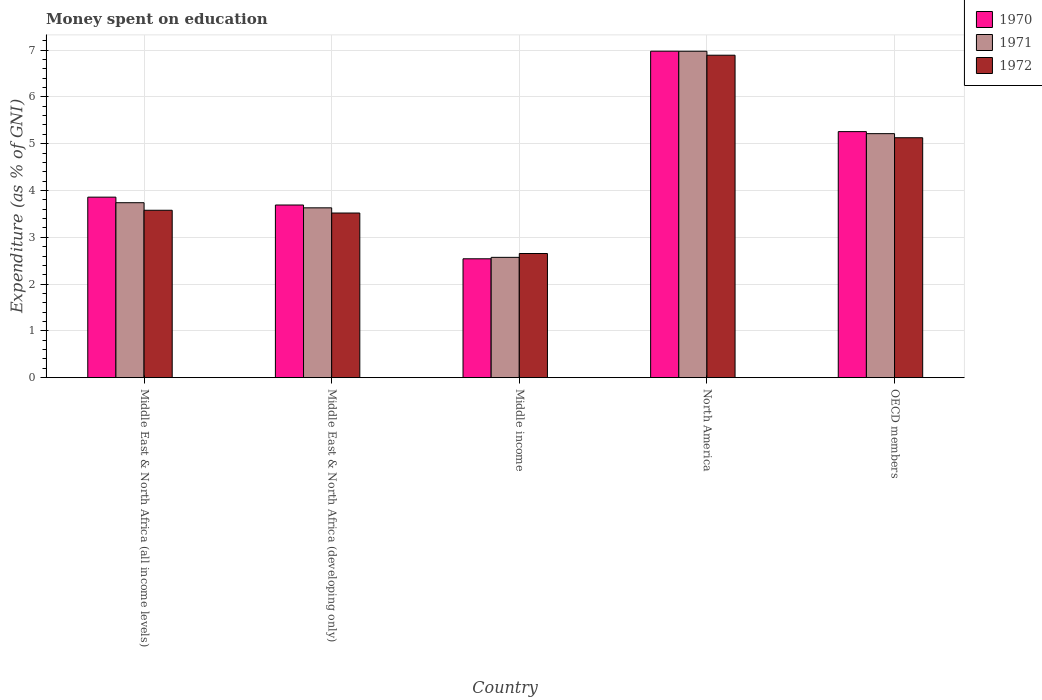How many different coloured bars are there?
Your answer should be very brief. 3. Are the number of bars on each tick of the X-axis equal?
Ensure brevity in your answer.  Yes. How many bars are there on the 3rd tick from the left?
Your answer should be compact. 3. What is the label of the 5th group of bars from the left?
Your answer should be very brief. OECD members. What is the amount of money spent on education in 1970 in Middle East & North Africa (developing only)?
Give a very brief answer. 3.69. Across all countries, what is the maximum amount of money spent on education in 1972?
Keep it short and to the point. 6.89. Across all countries, what is the minimum amount of money spent on education in 1971?
Offer a very short reply. 2.57. What is the total amount of money spent on education in 1972 in the graph?
Keep it short and to the point. 21.77. What is the difference between the amount of money spent on education in 1972 in Middle East & North Africa (developing only) and that in Middle income?
Make the answer very short. 0.87. What is the difference between the amount of money spent on education in 1970 in OECD members and the amount of money spent on education in 1972 in Middle income?
Offer a terse response. 2.6. What is the average amount of money spent on education in 1972 per country?
Offer a very short reply. 4.35. What is the difference between the amount of money spent on education of/in 1972 and amount of money spent on education of/in 1970 in Middle East & North Africa (all income levels)?
Give a very brief answer. -0.28. What is the ratio of the amount of money spent on education in 1970 in Middle East & North Africa (all income levels) to that in North America?
Your answer should be very brief. 0.55. Is the amount of money spent on education in 1972 in Middle East & North Africa (all income levels) less than that in OECD members?
Make the answer very short. Yes. Is the difference between the amount of money spent on education in 1972 in Middle East & North Africa (all income levels) and Middle income greater than the difference between the amount of money spent on education in 1970 in Middle East & North Africa (all income levels) and Middle income?
Provide a short and direct response. No. What is the difference between the highest and the second highest amount of money spent on education in 1970?
Ensure brevity in your answer.  -1.4. What is the difference between the highest and the lowest amount of money spent on education in 1970?
Give a very brief answer. 4.44. Is it the case that in every country, the sum of the amount of money spent on education in 1972 and amount of money spent on education in 1971 is greater than the amount of money spent on education in 1970?
Your answer should be very brief. Yes. How many bars are there?
Your answer should be very brief. 15. Does the graph contain any zero values?
Provide a short and direct response. No. Where does the legend appear in the graph?
Give a very brief answer. Top right. How are the legend labels stacked?
Provide a short and direct response. Vertical. What is the title of the graph?
Provide a short and direct response. Money spent on education. What is the label or title of the Y-axis?
Offer a very short reply. Expenditure (as % of GNI). What is the Expenditure (as % of GNI) in 1970 in Middle East & North Africa (all income levels)?
Ensure brevity in your answer.  3.86. What is the Expenditure (as % of GNI) of 1971 in Middle East & North Africa (all income levels)?
Provide a short and direct response. 3.74. What is the Expenditure (as % of GNI) in 1972 in Middle East & North Africa (all income levels)?
Give a very brief answer. 3.58. What is the Expenditure (as % of GNI) of 1970 in Middle East & North Africa (developing only)?
Ensure brevity in your answer.  3.69. What is the Expenditure (as % of GNI) of 1971 in Middle East & North Africa (developing only)?
Ensure brevity in your answer.  3.63. What is the Expenditure (as % of GNI) of 1972 in Middle East & North Africa (developing only)?
Offer a terse response. 3.52. What is the Expenditure (as % of GNI) in 1970 in Middle income?
Ensure brevity in your answer.  2.54. What is the Expenditure (as % of GNI) of 1971 in Middle income?
Your response must be concise. 2.57. What is the Expenditure (as % of GNI) of 1972 in Middle income?
Offer a terse response. 2.65. What is the Expenditure (as % of GNI) in 1970 in North America?
Your answer should be compact. 6.98. What is the Expenditure (as % of GNI) of 1971 in North America?
Give a very brief answer. 6.98. What is the Expenditure (as % of GNI) in 1972 in North America?
Your answer should be very brief. 6.89. What is the Expenditure (as % of GNI) in 1970 in OECD members?
Provide a succinct answer. 5.26. What is the Expenditure (as % of GNI) in 1971 in OECD members?
Provide a succinct answer. 5.21. What is the Expenditure (as % of GNI) of 1972 in OECD members?
Your response must be concise. 5.13. Across all countries, what is the maximum Expenditure (as % of GNI) of 1970?
Offer a terse response. 6.98. Across all countries, what is the maximum Expenditure (as % of GNI) of 1971?
Offer a terse response. 6.98. Across all countries, what is the maximum Expenditure (as % of GNI) in 1972?
Offer a terse response. 6.89. Across all countries, what is the minimum Expenditure (as % of GNI) in 1970?
Provide a succinct answer. 2.54. Across all countries, what is the minimum Expenditure (as % of GNI) in 1971?
Give a very brief answer. 2.57. Across all countries, what is the minimum Expenditure (as % of GNI) of 1972?
Your answer should be compact. 2.65. What is the total Expenditure (as % of GNI) of 1970 in the graph?
Give a very brief answer. 22.32. What is the total Expenditure (as % of GNI) in 1971 in the graph?
Offer a very short reply. 22.13. What is the total Expenditure (as % of GNI) of 1972 in the graph?
Offer a very short reply. 21.77. What is the difference between the Expenditure (as % of GNI) of 1970 in Middle East & North Africa (all income levels) and that in Middle East & North Africa (developing only)?
Keep it short and to the point. 0.17. What is the difference between the Expenditure (as % of GNI) of 1971 in Middle East & North Africa (all income levels) and that in Middle East & North Africa (developing only)?
Offer a terse response. 0.11. What is the difference between the Expenditure (as % of GNI) in 1972 in Middle East & North Africa (all income levels) and that in Middle East & North Africa (developing only)?
Your answer should be compact. 0.06. What is the difference between the Expenditure (as % of GNI) of 1970 in Middle East & North Africa (all income levels) and that in Middle income?
Provide a short and direct response. 1.32. What is the difference between the Expenditure (as % of GNI) in 1971 in Middle East & North Africa (all income levels) and that in Middle income?
Your answer should be very brief. 1.17. What is the difference between the Expenditure (as % of GNI) of 1972 in Middle East & North Africa (all income levels) and that in Middle income?
Provide a short and direct response. 0.92. What is the difference between the Expenditure (as % of GNI) of 1970 in Middle East & North Africa (all income levels) and that in North America?
Your response must be concise. -3.12. What is the difference between the Expenditure (as % of GNI) of 1971 in Middle East & North Africa (all income levels) and that in North America?
Provide a succinct answer. -3.24. What is the difference between the Expenditure (as % of GNI) in 1972 in Middle East & North Africa (all income levels) and that in North America?
Ensure brevity in your answer.  -3.31. What is the difference between the Expenditure (as % of GNI) of 1970 in Middle East & North Africa (all income levels) and that in OECD members?
Make the answer very short. -1.4. What is the difference between the Expenditure (as % of GNI) of 1971 in Middle East & North Africa (all income levels) and that in OECD members?
Provide a succinct answer. -1.48. What is the difference between the Expenditure (as % of GNI) of 1972 in Middle East & North Africa (all income levels) and that in OECD members?
Your answer should be compact. -1.55. What is the difference between the Expenditure (as % of GNI) of 1970 in Middle East & North Africa (developing only) and that in Middle income?
Ensure brevity in your answer.  1.15. What is the difference between the Expenditure (as % of GNI) in 1971 in Middle East & North Africa (developing only) and that in Middle income?
Your answer should be compact. 1.06. What is the difference between the Expenditure (as % of GNI) in 1972 in Middle East & North Africa (developing only) and that in Middle income?
Your response must be concise. 0.86. What is the difference between the Expenditure (as % of GNI) of 1970 in Middle East & North Africa (developing only) and that in North America?
Keep it short and to the point. -3.29. What is the difference between the Expenditure (as % of GNI) in 1971 in Middle East & North Africa (developing only) and that in North America?
Offer a terse response. -3.35. What is the difference between the Expenditure (as % of GNI) in 1972 in Middle East & North Africa (developing only) and that in North America?
Provide a succinct answer. -3.37. What is the difference between the Expenditure (as % of GNI) of 1970 in Middle East & North Africa (developing only) and that in OECD members?
Make the answer very short. -1.57. What is the difference between the Expenditure (as % of GNI) in 1971 in Middle East & North Africa (developing only) and that in OECD members?
Your answer should be compact. -1.59. What is the difference between the Expenditure (as % of GNI) in 1972 in Middle East & North Africa (developing only) and that in OECD members?
Your answer should be compact. -1.61. What is the difference between the Expenditure (as % of GNI) in 1970 in Middle income and that in North America?
Provide a succinct answer. -4.44. What is the difference between the Expenditure (as % of GNI) in 1971 in Middle income and that in North America?
Your response must be concise. -4.41. What is the difference between the Expenditure (as % of GNI) in 1972 in Middle income and that in North America?
Offer a very short reply. -4.24. What is the difference between the Expenditure (as % of GNI) of 1970 in Middle income and that in OECD members?
Make the answer very short. -2.72. What is the difference between the Expenditure (as % of GNI) in 1971 in Middle income and that in OECD members?
Offer a very short reply. -2.64. What is the difference between the Expenditure (as % of GNI) of 1972 in Middle income and that in OECD members?
Make the answer very short. -2.47. What is the difference between the Expenditure (as % of GNI) of 1970 in North America and that in OECD members?
Provide a short and direct response. 1.72. What is the difference between the Expenditure (as % of GNI) in 1971 in North America and that in OECD members?
Offer a terse response. 1.76. What is the difference between the Expenditure (as % of GNI) of 1972 in North America and that in OECD members?
Your response must be concise. 1.76. What is the difference between the Expenditure (as % of GNI) in 1970 in Middle East & North Africa (all income levels) and the Expenditure (as % of GNI) in 1971 in Middle East & North Africa (developing only)?
Offer a very short reply. 0.23. What is the difference between the Expenditure (as % of GNI) in 1970 in Middle East & North Africa (all income levels) and the Expenditure (as % of GNI) in 1972 in Middle East & North Africa (developing only)?
Provide a succinct answer. 0.34. What is the difference between the Expenditure (as % of GNI) in 1971 in Middle East & North Africa (all income levels) and the Expenditure (as % of GNI) in 1972 in Middle East & North Africa (developing only)?
Your answer should be very brief. 0.22. What is the difference between the Expenditure (as % of GNI) of 1970 in Middle East & North Africa (all income levels) and the Expenditure (as % of GNI) of 1971 in Middle income?
Your answer should be very brief. 1.29. What is the difference between the Expenditure (as % of GNI) of 1970 in Middle East & North Africa (all income levels) and the Expenditure (as % of GNI) of 1972 in Middle income?
Your answer should be very brief. 1.2. What is the difference between the Expenditure (as % of GNI) in 1971 in Middle East & North Africa (all income levels) and the Expenditure (as % of GNI) in 1972 in Middle income?
Your answer should be very brief. 1.09. What is the difference between the Expenditure (as % of GNI) of 1970 in Middle East & North Africa (all income levels) and the Expenditure (as % of GNI) of 1971 in North America?
Your answer should be very brief. -3.12. What is the difference between the Expenditure (as % of GNI) in 1970 in Middle East & North Africa (all income levels) and the Expenditure (as % of GNI) in 1972 in North America?
Ensure brevity in your answer.  -3.03. What is the difference between the Expenditure (as % of GNI) of 1971 in Middle East & North Africa (all income levels) and the Expenditure (as % of GNI) of 1972 in North America?
Make the answer very short. -3.15. What is the difference between the Expenditure (as % of GNI) in 1970 in Middle East & North Africa (all income levels) and the Expenditure (as % of GNI) in 1971 in OECD members?
Give a very brief answer. -1.36. What is the difference between the Expenditure (as % of GNI) of 1970 in Middle East & North Africa (all income levels) and the Expenditure (as % of GNI) of 1972 in OECD members?
Keep it short and to the point. -1.27. What is the difference between the Expenditure (as % of GNI) in 1971 in Middle East & North Africa (all income levels) and the Expenditure (as % of GNI) in 1972 in OECD members?
Provide a short and direct response. -1.39. What is the difference between the Expenditure (as % of GNI) of 1970 in Middle East & North Africa (developing only) and the Expenditure (as % of GNI) of 1971 in Middle income?
Your response must be concise. 1.12. What is the difference between the Expenditure (as % of GNI) of 1970 in Middle East & North Africa (developing only) and the Expenditure (as % of GNI) of 1972 in Middle income?
Offer a terse response. 1.04. What is the difference between the Expenditure (as % of GNI) in 1971 in Middle East & North Africa (developing only) and the Expenditure (as % of GNI) in 1972 in Middle income?
Ensure brevity in your answer.  0.98. What is the difference between the Expenditure (as % of GNI) of 1970 in Middle East & North Africa (developing only) and the Expenditure (as % of GNI) of 1971 in North America?
Keep it short and to the point. -3.29. What is the difference between the Expenditure (as % of GNI) in 1970 in Middle East & North Africa (developing only) and the Expenditure (as % of GNI) in 1972 in North America?
Your answer should be compact. -3.2. What is the difference between the Expenditure (as % of GNI) of 1971 in Middle East & North Africa (developing only) and the Expenditure (as % of GNI) of 1972 in North America?
Keep it short and to the point. -3.26. What is the difference between the Expenditure (as % of GNI) of 1970 in Middle East & North Africa (developing only) and the Expenditure (as % of GNI) of 1971 in OECD members?
Provide a short and direct response. -1.52. What is the difference between the Expenditure (as % of GNI) of 1970 in Middle East & North Africa (developing only) and the Expenditure (as % of GNI) of 1972 in OECD members?
Give a very brief answer. -1.44. What is the difference between the Expenditure (as % of GNI) of 1971 in Middle East & North Africa (developing only) and the Expenditure (as % of GNI) of 1972 in OECD members?
Give a very brief answer. -1.5. What is the difference between the Expenditure (as % of GNI) of 1970 in Middle income and the Expenditure (as % of GNI) of 1971 in North America?
Your answer should be very brief. -4.44. What is the difference between the Expenditure (as % of GNI) in 1970 in Middle income and the Expenditure (as % of GNI) in 1972 in North America?
Keep it short and to the point. -4.35. What is the difference between the Expenditure (as % of GNI) of 1971 in Middle income and the Expenditure (as % of GNI) of 1972 in North America?
Keep it short and to the point. -4.32. What is the difference between the Expenditure (as % of GNI) in 1970 in Middle income and the Expenditure (as % of GNI) in 1971 in OECD members?
Your response must be concise. -2.67. What is the difference between the Expenditure (as % of GNI) in 1970 in Middle income and the Expenditure (as % of GNI) in 1972 in OECD members?
Provide a short and direct response. -2.59. What is the difference between the Expenditure (as % of GNI) in 1971 in Middle income and the Expenditure (as % of GNI) in 1972 in OECD members?
Your answer should be compact. -2.56. What is the difference between the Expenditure (as % of GNI) in 1970 in North America and the Expenditure (as % of GNI) in 1971 in OECD members?
Your answer should be very brief. 1.76. What is the difference between the Expenditure (as % of GNI) of 1970 in North America and the Expenditure (as % of GNI) of 1972 in OECD members?
Make the answer very short. 1.85. What is the difference between the Expenditure (as % of GNI) of 1971 in North America and the Expenditure (as % of GNI) of 1972 in OECD members?
Make the answer very short. 1.85. What is the average Expenditure (as % of GNI) in 1970 per country?
Provide a short and direct response. 4.46. What is the average Expenditure (as % of GNI) in 1971 per country?
Offer a terse response. 4.43. What is the average Expenditure (as % of GNI) of 1972 per country?
Your response must be concise. 4.35. What is the difference between the Expenditure (as % of GNI) in 1970 and Expenditure (as % of GNI) in 1971 in Middle East & North Africa (all income levels)?
Your response must be concise. 0.12. What is the difference between the Expenditure (as % of GNI) of 1970 and Expenditure (as % of GNI) of 1972 in Middle East & North Africa (all income levels)?
Provide a short and direct response. 0.28. What is the difference between the Expenditure (as % of GNI) in 1971 and Expenditure (as % of GNI) in 1972 in Middle East & North Africa (all income levels)?
Provide a short and direct response. 0.16. What is the difference between the Expenditure (as % of GNI) in 1970 and Expenditure (as % of GNI) in 1971 in Middle East & North Africa (developing only)?
Offer a terse response. 0.06. What is the difference between the Expenditure (as % of GNI) in 1970 and Expenditure (as % of GNI) in 1972 in Middle East & North Africa (developing only)?
Your answer should be very brief. 0.17. What is the difference between the Expenditure (as % of GNI) in 1971 and Expenditure (as % of GNI) in 1972 in Middle East & North Africa (developing only)?
Provide a succinct answer. 0.11. What is the difference between the Expenditure (as % of GNI) of 1970 and Expenditure (as % of GNI) of 1971 in Middle income?
Your answer should be very brief. -0.03. What is the difference between the Expenditure (as % of GNI) in 1970 and Expenditure (as % of GNI) in 1972 in Middle income?
Your answer should be very brief. -0.11. What is the difference between the Expenditure (as % of GNI) of 1971 and Expenditure (as % of GNI) of 1972 in Middle income?
Offer a very short reply. -0.08. What is the difference between the Expenditure (as % of GNI) of 1970 and Expenditure (as % of GNI) of 1971 in North America?
Offer a very short reply. 0. What is the difference between the Expenditure (as % of GNI) of 1970 and Expenditure (as % of GNI) of 1972 in North America?
Make the answer very short. 0.09. What is the difference between the Expenditure (as % of GNI) of 1971 and Expenditure (as % of GNI) of 1972 in North America?
Your response must be concise. 0.08. What is the difference between the Expenditure (as % of GNI) in 1970 and Expenditure (as % of GNI) in 1971 in OECD members?
Keep it short and to the point. 0.04. What is the difference between the Expenditure (as % of GNI) of 1970 and Expenditure (as % of GNI) of 1972 in OECD members?
Your answer should be compact. 0.13. What is the difference between the Expenditure (as % of GNI) of 1971 and Expenditure (as % of GNI) of 1972 in OECD members?
Your answer should be compact. 0.09. What is the ratio of the Expenditure (as % of GNI) of 1970 in Middle East & North Africa (all income levels) to that in Middle East & North Africa (developing only)?
Provide a short and direct response. 1.05. What is the ratio of the Expenditure (as % of GNI) in 1971 in Middle East & North Africa (all income levels) to that in Middle East & North Africa (developing only)?
Provide a short and direct response. 1.03. What is the ratio of the Expenditure (as % of GNI) of 1972 in Middle East & North Africa (all income levels) to that in Middle East & North Africa (developing only)?
Offer a very short reply. 1.02. What is the ratio of the Expenditure (as % of GNI) in 1970 in Middle East & North Africa (all income levels) to that in Middle income?
Your response must be concise. 1.52. What is the ratio of the Expenditure (as % of GNI) in 1971 in Middle East & North Africa (all income levels) to that in Middle income?
Your answer should be very brief. 1.45. What is the ratio of the Expenditure (as % of GNI) in 1972 in Middle East & North Africa (all income levels) to that in Middle income?
Make the answer very short. 1.35. What is the ratio of the Expenditure (as % of GNI) in 1970 in Middle East & North Africa (all income levels) to that in North America?
Offer a terse response. 0.55. What is the ratio of the Expenditure (as % of GNI) of 1971 in Middle East & North Africa (all income levels) to that in North America?
Your answer should be very brief. 0.54. What is the ratio of the Expenditure (as % of GNI) in 1972 in Middle East & North Africa (all income levels) to that in North America?
Keep it short and to the point. 0.52. What is the ratio of the Expenditure (as % of GNI) in 1970 in Middle East & North Africa (all income levels) to that in OECD members?
Provide a succinct answer. 0.73. What is the ratio of the Expenditure (as % of GNI) in 1971 in Middle East & North Africa (all income levels) to that in OECD members?
Provide a succinct answer. 0.72. What is the ratio of the Expenditure (as % of GNI) in 1972 in Middle East & North Africa (all income levels) to that in OECD members?
Your response must be concise. 0.7. What is the ratio of the Expenditure (as % of GNI) in 1970 in Middle East & North Africa (developing only) to that in Middle income?
Your answer should be very brief. 1.45. What is the ratio of the Expenditure (as % of GNI) of 1971 in Middle East & North Africa (developing only) to that in Middle income?
Your answer should be very brief. 1.41. What is the ratio of the Expenditure (as % of GNI) in 1972 in Middle East & North Africa (developing only) to that in Middle income?
Provide a succinct answer. 1.33. What is the ratio of the Expenditure (as % of GNI) in 1970 in Middle East & North Africa (developing only) to that in North America?
Your answer should be compact. 0.53. What is the ratio of the Expenditure (as % of GNI) in 1971 in Middle East & North Africa (developing only) to that in North America?
Ensure brevity in your answer.  0.52. What is the ratio of the Expenditure (as % of GNI) in 1972 in Middle East & North Africa (developing only) to that in North America?
Your answer should be very brief. 0.51. What is the ratio of the Expenditure (as % of GNI) of 1970 in Middle East & North Africa (developing only) to that in OECD members?
Provide a succinct answer. 0.7. What is the ratio of the Expenditure (as % of GNI) in 1971 in Middle East & North Africa (developing only) to that in OECD members?
Make the answer very short. 0.7. What is the ratio of the Expenditure (as % of GNI) in 1972 in Middle East & North Africa (developing only) to that in OECD members?
Offer a very short reply. 0.69. What is the ratio of the Expenditure (as % of GNI) in 1970 in Middle income to that in North America?
Ensure brevity in your answer.  0.36. What is the ratio of the Expenditure (as % of GNI) of 1971 in Middle income to that in North America?
Ensure brevity in your answer.  0.37. What is the ratio of the Expenditure (as % of GNI) in 1972 in Middle income to that in North America?
Ensure brevity in your answer.  0.39. What is the ratio of the Expenditure (as % of GNI) of 1970 in Middle income to that in OECD members?
Provide a short and direct response. 0.48. What is the ratio of the Expenditure (as % of GNI) in 1971 in Middle income to that in OECD members?
Ensure brevity in your answer.  0.49. What is the ratio of the Expenditure (as % of GNI) in 1972 in Middle income to that in OECD members?
Your answer should be very brief. 0.52. What is the ratio of the Expenditure (as % of GNI) of 1970 in North America to that in OECD members?
Provide a succinct answer. 1.33. What is the ratio of the Expenditure (as % of GNI) of 1971 in North America to that in OECD members?
Offer a terse response. 1.34. What is the ratio of the Expenditure (as % of GNI) of 1972 in North America to that in OECD members?
Give a very brief answer. 1.34. What is the difference between the highest and the second highest Expenditure (as % of GNI) in 1970?
Provide a short and direct response. 1.72. What is the difference between the highest and the second highest Expenditure (as % of GNI) of 1971?
Keep it short and to the point. 1.76. What is the difference between the highest and the second highest Expenditure (as % of GNI) of 1972?
Your answer should be very brief. 1.76. What is the difference between the highest and the lowest Expenditure (as % of GNI) in 1970?
Offer a terse response. 4.44. What is the difference between the highest and the lowest Expenditure (as % of GNI) in 1971?
Your answer should be very brief. 4.41. What is the difference between the highest and the lowest Expenditure (as % of GNI) of 1972?
Give a very brief answer. 4.24. 